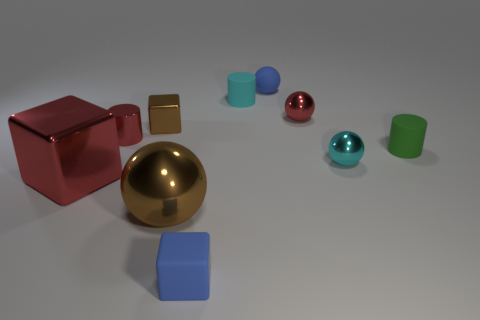Subtract all matte cylinders. How many cylinders are left? 1 Subtract all cyan cylinders. How many cylinders are left? 2 Subtract 1 cubes. How many cubes are left? 2 Add 3 small matte blocks. How many small matte blocks are left? 4 Add 10 green metallic blocks. How many green metallic blocks exist? 10 Subtract 1 green cylinders. How many objects are left? 9 Subtract all cylinders. How many objects are left? 7 Subtract all purple cylinders. Subtract all blue balls. How many cylinders are left? 3 Subtract all gray blocks. How many yellow balls are left? 0 Subtract all blocks. Subtract all tiny blue matte objects. How many objects are left? 5 